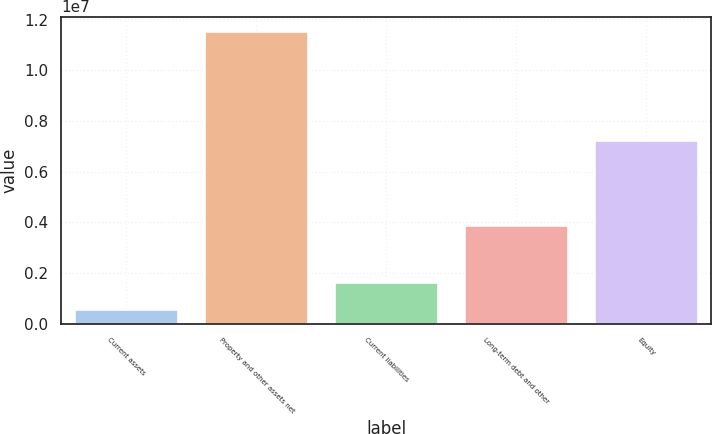Convert chart. <chart><loc_0><loc_0><loc_500><loc_500><bar_chart><fcel>Current assets<fcel>Property and other assets net<fcel>Current liabilities<fcel>Long-term debt and other<fcel>Equity<nl><fcel>555615<fcel>1.15464e+07<fcel>1.65469e+06<fcel>3.90809e+06<fcel>7.24848e+06<nl></chart> 